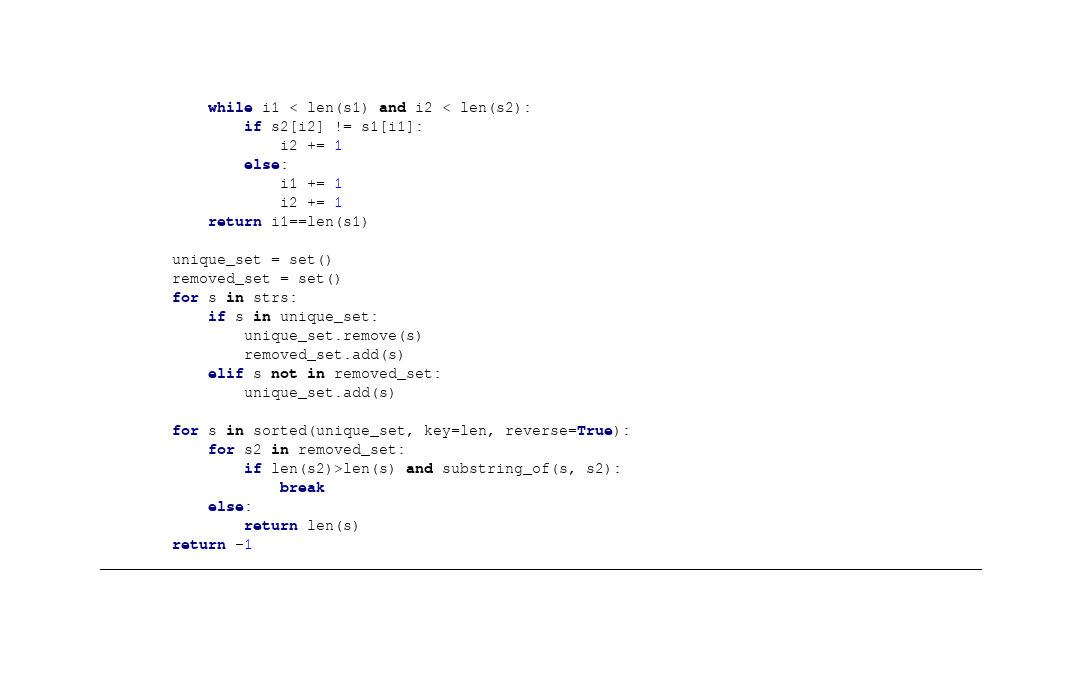Convert code to text. <code><loc_0><loc_0><loc_500><loc_500><_Python_>            while i1 < len(s1) and i2 < len(s2):
                if s2[i2] != s1[i1]:
                    i2 += 1
                else:
                    i1 += 1
                    i2 += 1
            return i1==len(s1)
        
        unique_set = set()
        removed_set = set()
        for s in strs:
            if s in unique_set:
                unique_set.remove(s)
                removed_set.add(s)
            elif s not in removed_set:
                unique_set.add(s)

        for s in sorted(unique_set, key=len, reverse=True):
            for s2 in removed_set:
                if len(s2)>len(s) and substring_of(s, s2):
                    break
            else:
                return len(s)
        return -1
__________________________________________________________________________________________________
</code> 